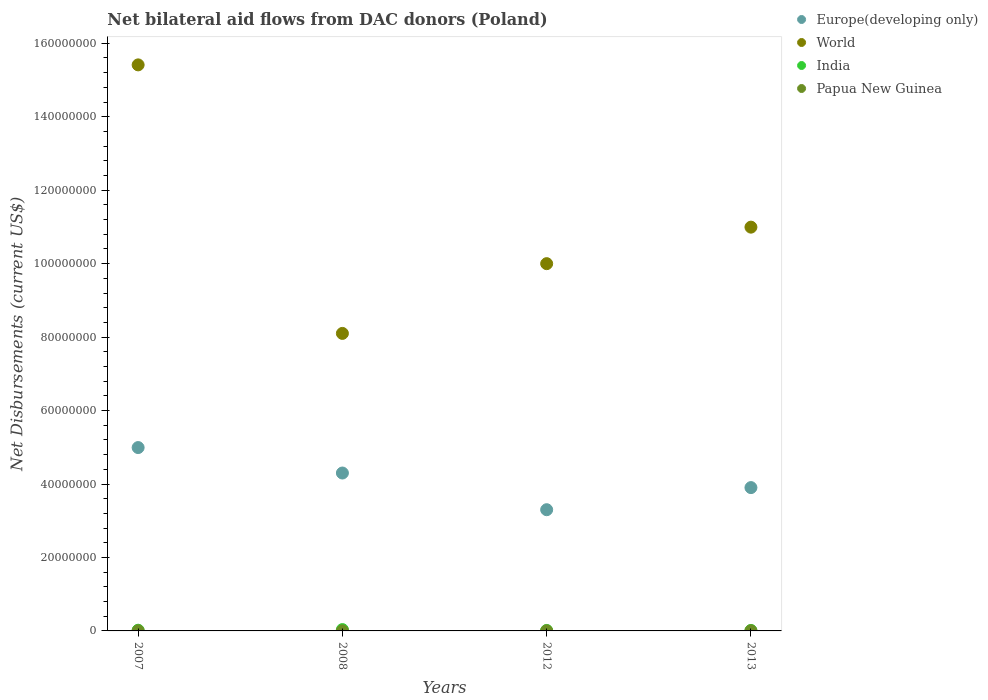How many different coloured dotlines are there?
Your answer should be very brief. 4. Is the number of dotlines equal to the number of legend labels?
Provide a short and direct response. Yes. What is the net bilateral aid flows in World in 2013?
Provide a short and direct response. 1.10e+08. Across all years, what is the maximum net bilateral aid flows in World?
Your response must be concise. 1.54e+08. Across all years, what is the minimum net bilateral aid flows in India?
Keep it short and to the point. 1.30e+05. In which year was the net bilateral aid flows in Papua New Guinea maximum?
Provide a succinct answer. 2007. In which year was the net bilateral aid flows in Europe(developing only) minimum?
Provide a succinct answer. 2012. What is the total net bilateral aid flows in Europe(developing only) in the graph?
Your answer should be very brief. 1.65e+08. What is the difference between the net bilateral aid flows in World in 2008 and that in 2013?
Make the answer very short. -2.89e+07. What is the difference between the net bilateral aid flows in India in 2012 and the net bilateral aid flows in Papua New Guinea in 2007?
Offer a terse response. 1.00e+05. What is the average net bilateral aid flows in World per year?
Make the answer very short. 1.11e+08. In the year 2008, what is the difference between the net bilateral aid flows in Papua New Guinea and net bilateral aid flows in World?
Offer a terse response. -8.10e+07. In how many years, is the net bilateral aid flows in Papua New Guinea greater than 132000000 US$?
Your answer should be compact. 0. What is the difference between the highest and the second highest net bilateral aid flows in World?
Your response must be concise. 4.42e+07. What is the difference between the highest and the lowest net bilateral aid flows in India?
Offer a very short reply. 2.30e+05. In how many years, is the net bilateral aid flows in World greater than the average net bilateral aid flows in World taken over all years?
Your answer should be compact. 1. Is the sum of the net bilateral aid flows in Europe(developing only) in 2008 and 2013 greater than the maximum net bilateral aid flows in World across all years?
Give a very brief answer. No. Is it the case that in every year, the sum of the net bilateral aid flows in India and net bilateral aid flows in World  is greater than the sum of net bilateral aid flows in Papua New Guinea and net bilateral aid flows in Europe(developing only)?
Offer a terse response. No. Does the net bilateral aid flows in World monotonically increase over the years?
Your response must be concise. No. Is the net bilateral aid flows in Europe(developing only) strictly greater than the net bilateral aid flows in Papua New Guinea over the years?
Ensure brevity in your answer.  Yes. What is the difference between two consecutive major ticks on the Y-axis?
Ensure brevity in your answer.  2.00e+07. Are the values on the major ticks of Y-axis written in scientific E-notation?
Keep it short and to the point. No. Does the graph contain grids?
Your response must be concise. No. How many legend labels are there?
Your answer should be compact. 4. What is the title of the graph?
Provide a short and direct response. Net bilateral aid flows from DAC donors (Poland). What is the label or title of the X-axis?
Offer a terse response. Years. What is the label or title of the Y-axis?
Your answer should be compact. Net Disbursements (current US$). What is the Net Disbursements (current US$) in Europe(developing only) in 2007?
Your response must be concise. 4.99e+07. What is the Net Disbursements (current US$) of World in 2007?
Offer a very short reply. 1.54e+08. What is the Net Disbursements (current US$) in India in 2007?
Your answer should be very brief. 1.90e+05. What is the Net Disbursements (current US$) in Europe(developing only) in 2008?
Provide a short and direct response. 4.30e+07. What is the Net Disbursements (current US$) in World in 2008?
Your answer should be very brief. 8.10e+07. What is the Net Disbursements (current US$) in India in 2008?
Give a very brief answer. 3.60e+05. What is the Net Disbursements (current US$) of Europe(developing only) in 2012?
Your answer should be very brief. 3.30e+07. What is the Net Disbursements (current US$) in World in 2012?
Your answer should be compact. 1.00e+08. What is the Net Disbursements (current US$) of India in 2012?
Keep it short and to the point. 1.30e+05. What is the Net Disbursements (current US$) in Papua New Guinea in 2012?
Your answer should be compact. 2.00e+04. What is the Net Disbursements (current US$) in Europe(developing only) in 2013?
Your answer should be very brief. 3.90e+07. What is the Net Disbursements (current US$) in World in 2013?
Your answer should be very brief. 1.10e+08. Across all years, what is the maximum Net Disbursements (current US$) in Europe(developing only)?
Make the answer very short. 4.99e+07. Across all years, what is the maximum Net Disbursements (current US$) of World?
Provide a succinct answer. 1.54e+08. Across all years, what is the maximum Net Disbursements (current US$) of India?
Your response must be concise. 3.60e+05. Across all years, what is the maximum Net Disbursements (current US$) of Papua New Guinea?
Your answer should be very brief. 3.00e+04. Across all years, what is the minimum Net Disbursements (current US$) of Europe(developing only)?
Your answer should be very brief. 3.30e+07. Across all years, what is the minimum Net Disbursements (current US$) in World?
Make the answer very short. 8.10e+07. What is the total Net Disbursements (current US$) of Europe(developing only) in the graph?
Offer a terse response. 1.65e+08. What is the total Net Disbursements (current US$) in World in the graph?
Make the answer very short. 4.45e+08. What is the total Net Disbursements (current US$) in India in the graph?
Provide a succinct answer. 8.10e+05. What is the total Net Disbursements (current US$) in Papua New Guinea in the graph?
Offer a terse response. 8.00e+04. What is the difference between the Net Disbursements (current US$) of Europe(developing only) in 2007 and that in 2008?
Keep it short and to the point. 6.93e+06. What is the difference between the Net Disbursements (current US$) of World in 2007 and that in 2008?
Your response must be concise. 7.31e+07. What is the difference between the Net Disbursements (current US$) of India in 2007 and that in 2008?
Your response must be concise. -1.70e+05. What is the difference between the Net Disbursements (current US$) of Papua New Guinea in 2007 and that in 2008?
Your response must be concise. 2.00e+04. What is the difference between the Net Disbursements (current US$) of Europe(developing only) in 2007 and that in 2012?
Offer a terse response. 1.69e+07. What is the difference between the Net Disbursements (current US$) in World in 2007 and that in 2012?
Your response must be concise. 5.41e+07. What is the difference between the Net Disbursements (current US$) in India in 2007 and that in 2012?
Your answer should be very brief. 6.00e+04. What is the difference between the Net Disbursements (current US$) of Europe(developing only) in 2007 and that in 2013?
Offer a terse response. 1.09e+07. What is the difference between the Net Disbursements (current US$) of World in 2007 and that in 2013?
Provide a succinct answer. 4.42e+07. What is the difference between the Net Disbursements (current US$) in India in 2007 and that in 2013?
Provide a succinct answer. 6.00e+04. What is the difference between the Net Disbursements (current US$) in Europe(developing only) in 2008 and that in 2012?
Offer a terse response. 9.99e+06. What is the difference between the Net Disbursements (current US$) of World in 2008 and that in 2012?
Give a very brief answer. -1.90e+07. What is the difference between the Net Disbursements (current US$) in India in 2008 and that in 2012?
Offer a terse response. 2.30e+05. What is the difference between the Net Disbursements (current US$) of Papua New Guinea in 2008 and that in 2012?
Make the answer very short. -10000. What is the difference between the Net Disbursements (current US$) in Europe(developing only) in 2008 and that in 2013?
Your answer should be compact. 3.97e+06. What is the difference between the Net Disbursements (current US$) of World in 2008 and that in 2013?
Ensure brevity in your answer.  -2.89e+07. What is the difference between the Net Disbursements (current US$) of India in 2008 and that in 2013?
Offer a very short reply. 2.30e+05. What is the difference between the Net Disbursements (current US$) in Papua New Guinea in 2008 and that in 2013?
Your answer should be very brief. -10000. What is the difference between the Net Disbursements (current US$) in Europe(developing only) in 2012 and that in 2013?
Ensure brevity in your answer.  -6.02e+06. What is the difference between the Net Disbursements (current US$) of World in 2012 and that in 2013?
Keep it short and to the point. -9.94e+06. What is the difference between the Net Disbursements (current US$) of India in 2012 and that in 2013?
Your response must be concise. 0. What is the difference between the Net Disbursements (current US$) in Papua New Guinea in 2012 and that in 2013?
Provide a short and direct response. 0. What is the difference between the Net Disbursements (current US$) in Europe(developing only) in 2007 and the Net Disbursements (current US$) in World in 2008?
Provide a succinct answer. -3.11e+07. What is the difference between the Net Disbursements (current US$) of Europe(developing only) in 2007 and the Net Disbursements (current US$) of India in 2008?
Offer a very short reply. 4.96e+07. What is the difference between the Net Disbursements (current US$) in Europe(developing only) in 2007 and the Net Disbursements (current US$) in Papua New Guinea in 2008?
Offer a very short reply. 4.99e+07. What is the difference between the Net Disbursements (current US$) of World in 2007 and the Net Disbursements (current US$) of India in 2008?
Keep it short and to the point. 1.54e+08. What is the difference between the Net Disbursements (current US$) of World in 2007 and the Net Disbursements (current US$) of Papua New Guinea in 2008?
Your response must be concise. 1.54e+08. What is the difference between the Net Disbursements (current US$) of Europe(developing only) in 2007 and the Net Disbursements (current US$) of World in 2012?
Provide a short and direct response. -5.01e+07. What is the difference between the Net Disbursements (current US$) in Europe(developing only) in 2007 and the Net Disbursements (current US$) in India in 2012?
Provide a short and direct response. 4.98e+07. What is the difference between the Net Disbursements (current US$) in Europe(developing only) in 2007 and the Net Disbursements (current US$) in Papua New Guinea in 2012?
Give a very brief answer. 4.99e+07. What is the difference between the Net Disbursements (current US$) in World in 2007 and the Net Disbursements (current US$) in India in 2012?
Offer a terse response. 1.54e+08. What is the difference between the Net Disbursements (current US$) in World in 2007 and the Net Disbursements (current US$) in Papua New Guinea in 2012?
Keep it short and to the point. 1.54e+08. What is the difference between the Net Disbursements (current US$) of India in 2007 and the Net Disbursements (current US$) of Papua New Guinea in 2012?
Make the answer very short. 1.70e+05. What is the difference between the Net Disbursements (current US$) in Europe(developing only) in 2007 and the Net Disbursements (current US$) in World in 2013?
Provide a succinct answer. -6.00e+07. What is the difference between the Net Disbursements (current US$) in Europe(developing only) in 2007 and the Net Disbursements (current US$) in India in 2013?
Offer a terse response. 4.98e+07. What is the difference between the Net Disbursements (current US$) in Europe(developing only) in 2007 and the Net Disbursements (current US$) in Papua New Guinea in 2013?
Offer a very short reply. 4.99e+07. What is the difference between the Net Disbursements (current US$) of World in 2007 and the Net Disbursements (current US$) of India in 2013?
Offer a terse response. 1.54e+08. What is the difference between the Net Disbursements (current US$) of World in 2007 and the Net Disbursements (current US$) of Papua New Guinea in 2013?
Your answer should be very brief. 1.54e+08. What is the difference between the Net Disbursements (current US$) in India in 2007 and the Net Disbursements (current US$) in Papua New Guinea in 2013?
Provide a succinct answer. 1.70e+05. What is the difference between the Net Disbursements (current US$) of Europe(developing only) in 2008 and the Net Disbursements (current US$) of World in 2012?
Keep it short and to the point. -5.70e+07. What is the difference between the Net Disbursements (current US$) in Europe(developing only) in 2008 and the Net Disbursements (current US$) in India in 2012?
Ensure brevity in your answer.  4.29e+07. What is the difference between the Net Disbursements (current US$) of Europe(developing only) in 2008 and the Net Disbursements (current US$) of Papua New Guinea in 2012?
Offer a very short reply. 4.30e+07. What is the difference between the Net Disbursements (current US$) in World in 2008 and the Net Disbursements (current US$) in India in 2012?
Make the answer very short. 8.09e+07. What is the difference between the Net Disbursements (current US$) in World in 2008 and the Net Disbursements (current US$) in Papua New Guinea in 2012?
Your response must be concise. 8.10e+07. What is the difference between the Net Disbursements (current US$) of Europe(developing only) in 2008 and the Net Disbursements (current US$) of World in 2013?
Make the answer very short. -6.69e+07. What is the difference between the Net Disbursements (current US$) in Europe(developing only) in 2008 and the Net Disbursements (current US$) in India in 2013?
Provide a short and direct response. 4.29e+07. What is the difference between the Net Disbursements (current US$) in Europe(developing only) in 2008 and the Net Disbursements (current US$) in Papua New Guinea in 2013?
Provide a succinct answer. 4.30e+07. What is the difference between the Net Disbursements (current US$) of World in 2008 and the Net Disbursements (current US$) of India in 2013?
Make the answer very short. 8.09e+07. What is the difference between the Net Disbursements (current US$) of World in 2008 and the Net Disbursements (current US$) of Papua New Guinea in 2013?
Give a very brief answer. 8.10e+07. What is the difference between the Net Disbursements (current US$) in Europe(developing only) in 2012 and the Net Disbursements (current US$) in World in 2013?
Offer a very short reply. -7.69e+07. What is the difference between the Net Disbursements (current US$) of Europe(developing only) in 2012 and the Net Disbursements (current US$) of India in 2013?
Your answer should be compact. 3.29e+07. What is the difference between the Net Disbursements (current US$) of Europe(developing only) in 2012 and the Net Disbursements (current US$) of Papua New Guinea in 2013?
Keep it short and to the point. 3.30e+07. What is the difference between the Net Disbursements (current US$) in World in 2012 and the Net Disbursements (current US$) in India in 2013?
Give a very brief answer. 9.99e+07. What is the difference between the Net Disbursements (current US$) in World in 2012 and the Net Disbursements (current US$) in Papua New Guinea in 2013?
Provide a short and direct response. 1.00e+08. What is the average Net Disbursements (current US$) of Europe(developing only) per year?
Provide a succinct answer. 4.12e+07. What is the average Net Disbursements (current US$) in World per year?
Offer a terse response. 1.11e+08. What is the average Net Disbursements (current US$) of India per year?
Your response must be concise. 2.02e+05. In the year 2007, what is the difference between the Net Disbursements (current US$) of Europe(developing only) and Net Disbursements (current US$) of World?
Your response must be concise. -1.04e+08. In the year 2007, what is the difference between the Net Disbursements (current US$) of Europe(developing only) and Net Disbursements (current US$) of India?
Make the answer very short. 4.97e+07. In the year 2007, what is the difference between the Net Disbursements (current US$) in Europe(developing only) and Net Disbursements (current US$) in Papua New Guinea?
Offer a very short reply. 4.99e+07. In the year 2007, what is the difference between the Net Disbursements (current US$) of World and Net Disbursements (current US$) of India?
Make the answer very short. 1.54e+08. In the year 2007, what is the difference between the Net Disbursements (current US$) in World and Net Disbursements (current US$) in Papua New Guinea?
Make the answer very short. 1.54e+08. In the year 2007, what is the difference between the Net Disbursements (current US$) in India and Net Disbursements (current US$) in Papua New Guinea?
Keep it short and to the point. 1.60e+05. In the year 2008, what is the difference between the Net Disbursements (current US$) of Europe(developing only) and Net Disbursements (current US$) of World?
Keep it short and to the point. -3.80e+07. In the year 2008, what is the difference between the Net Disbursements (current US$) of Europe(developing only) and Net Disbursements (current US$) of India?
Keep it short and to the point. 4.26e+07. In the year 2008, what is the difference between the Net Disbursements (current US$) of Europe(developing only) and Net Disbursements (current US$) of Papua New Guinea?
Provide a succinct answer. 4.30e+07. In the year 2008, what is the difference between the Net Disbursements (current US$) of World and Net Disbursements (current US$) of India?
Your answer should be compact. 8.06e+07. In the year 2008, what is the difference between the Net Disbursements (current US$) in World and Net Disbursements (current US$) in Papua New Guinea?
Offer a very short reply. 8.10e+07. In the year 2012, what is the difference between the Net Disbursements (current US$) in Europe(developing only) and Net Disbursements (current US$) in World?
Provide a short and direct response. -6.70e+07. In the year 2012, what is the difference between the Net Disbursements (current US$) of Europe(developing only) and Net Disbursements (current US$) of India?
Offer a terse response. 3.29e+07. In the year 2012, what is the difference between the Net Disbursements (current US$) of Europe(developing only) and Net Disbursements (current US$) of Papua New Guinea?
Ensure brevity in your answer.  3.30e+07. In the year 2012, what is the difference between the Net Disbursements (current US$) in World and Net Disbursements (current US$) in India?
Your answer should be compact. 9.99e+07. In the year 2012, what is the difference between the Net Disbursements (current US$) in World and Net Disbursements (current US$) in Papua New Guinea?
Your answer should be very brief. 1.00e+08. In the year 2013, what is the difference between the Net Disbursements (current US$) of Europe(developing only) and Net Disbursements (current US$) of World?
Provide a short and direct response. -7.09e+07. In the year 2013, what is the difference between the Net Disbursements (current US$) of Europe(developing only) and Net Disbursements (current US$) of India?
Keep it short and to the point. 3.89e+07. In the year 2013, what is the difference between the Net Disbursements (current US$) of Europe(developing only) and Net Disbursements (current US$) of Papua New Guinea?
Give a very brief answer. 3.90e+07. In the year 2013, what is the difference between the Net Disbursements (current US$) of World and Net Disbursements (current US$) of India?
Ensure brevity in your answer.  1.10e+08. In the year 2013, what is the difference between the Net Disbursements (current US$) of World and Net Disbursements (current US$) of Papua New Guinea?
Give a very brief answer. 1.10e+08. In the year 2013, what is the difference between the Net Disbursements (current US$) of India and Net Disbursements (current US$) of Papua New Guinea?
Offer a very short reply. 1.10e+05. What is the ratio of the Net Disbursements (current US$) of Europe(developing only) in 2007 to that in 2008?
Ensure brevity in your answer.  1.16. What is the ratio of the Net Disbursements (current US$) of World in 2007 to that in 2008?
Give a very brief answer. 1.9. What is the ratio of the Net Disbursements (current US$) of India in 2007 to that in 2008?
Make the answer very short. 0.53. What is the ratio of the Net Disbursements (current US$) of Papua New Guinea in 2007 to that in 2008?
Offer a terse response. 3. What is the ratio of the Net Disbursements (current US$) of Europe(developing only) in 2007 to that in 2012?
Offer a very short reply. 1.51. What is the ratio of the Net Disbursements (current US$) of World in 2007 to that in 2012?
Give a very brief answer. 1.54. What is the ratio of the Net Disbursements (current US$) in India in 2007 to that in 2012?
Make the answer very short. 1.46. What is the ratio of the Net Disbursements (current US$) of Papua New Guinea in 2007 to that in 2012?
Make the answer very short. 1.5. What is the ratio of the Net Disbursements (current US$) of Europe(developing only) in 2007 to that in 2013?
Offer a very short reply. 1.28. What is the ratio of the Net Disbursements (current US$) of World in 2007 to that in 2013?
Give a very brief answer. 1.4. What is the ratio of the Net Disbursements (current US$) in India in 2007 to that in 2013?
Your answer should be compact. 1.46. What is the ratio of the Net Disbursements (current US$) of Europe(developing only) in 2008 to that in 2012?
Keep it short and to the point. 1.3. What is the ratio of the Net Disbursements (current US$) in World in 2008 to that in 2012?
Your response must be concise. 0.81. What is the ratio of the Net Disbursements (current US$) in India in 2008 to that in 2012?
Keep it short and to the point. 2.77. What is the ratio of the Net Disbursements (current US$) in Papua New Guinea in 2008 to that in 2012?
Provide a short and direct response. 0.5. What is the ratio of the Net Disbursements (current US$) in Europe(developing only) in 2008 to that in 2013?
Give a very brief answer. 1.1. What is the ratio of the Net Disbursements (current US$) of World in 2008 to that in 2013?
Provide a succinct answer. 0.74. What is the ratio of the Net Disbursements (current US$) of India in 2008 to that in 2013?
Offer a very short reply. 2.77. What is the ratio of the Net Disbursements (current US$) of Europe(developing only) in 2012 to that in 2013?
Your answer should be very brief. 0.85. What is the ratio of the Net Disbursements (current US$) of World in 2012 to that in 2013?
Give a very brief answer. 0.91. What is the difference between the highest and the second highest Net Disbursements (current US$) in Europe(developing only)?
Give a very brief answer. 6.93e+06. What is the difference between the highest and the second highest Net Disbursements (current US$) in World?
Your answer should be very brief. 4.42e+07. What is the difference between the highest and the second highest Net Disbursements (current US$) of India?
Provide a short and direct response. 1.70e+05. What is the difference between the highest and the second highest Net Disbursements (current US$) in Papua New Guinea?
Offer a terse response. 10000. What is the difference between the highest and the lowest Net Disbursements (current US$) of Europe(developing only)?
Give a very brief answer. 1.69e+07. What is the difference between the highest and the lowest Net Disbursements (current US$) in World?
Your answer should be compact. 7.31e+07. 